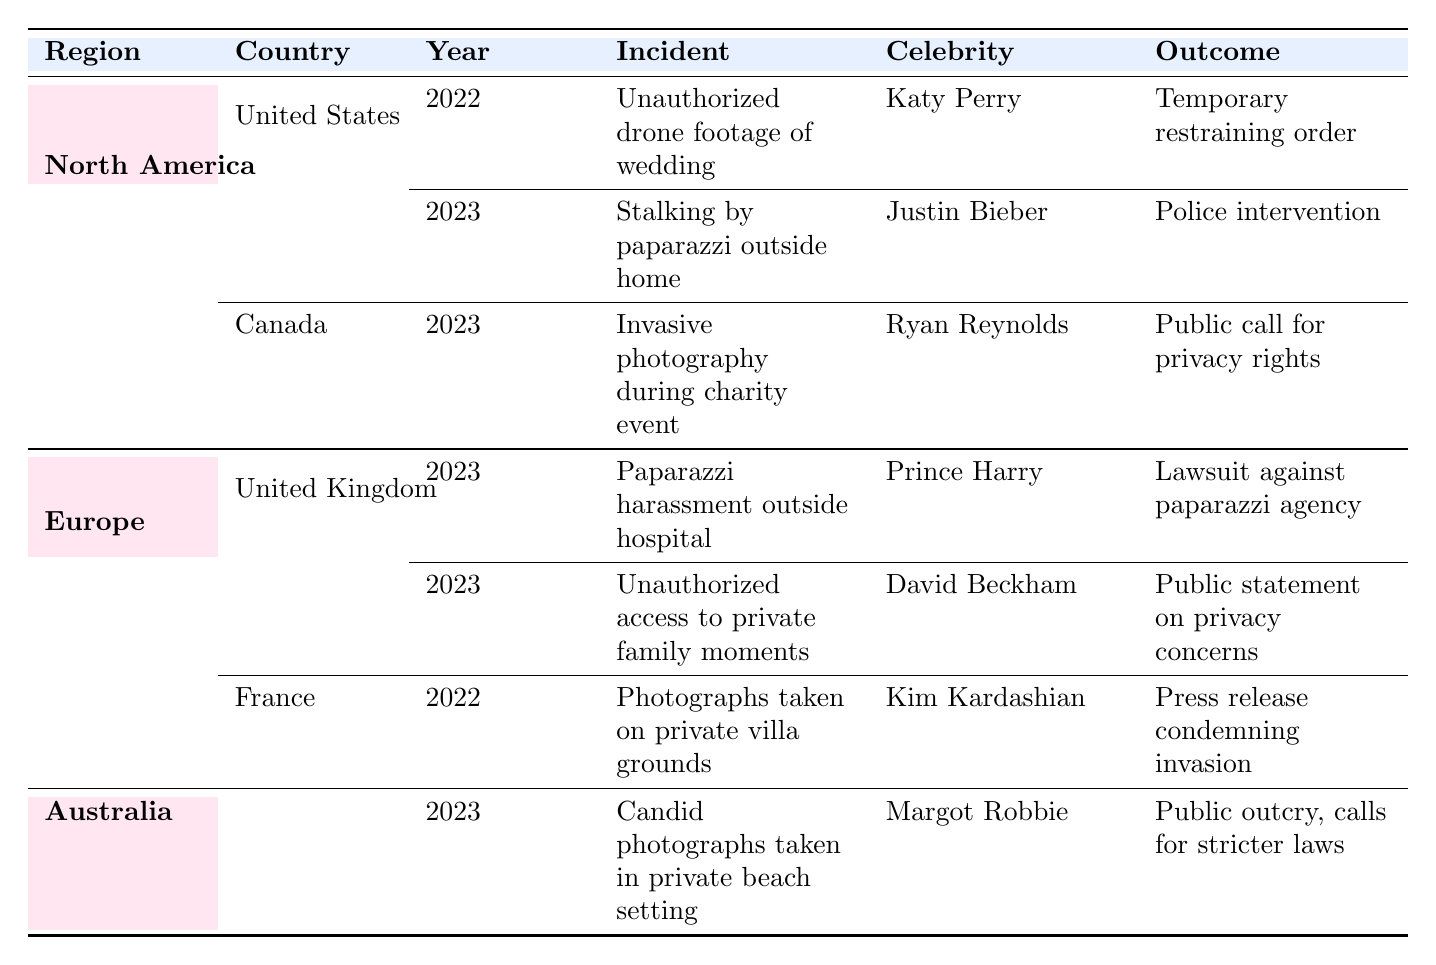What incidents occurred in the United States in 2023? There are two incidents listed for the United States in 2023: one involving "stalking by paparazzi outside a home" related to Justin Bieber, and there is no other incident in that year.
Answer: Stalking by paparazzi outside a home How many privacy invasion incidents were reported in Canada? There is one reported incident in Canada, which involved Ryan Reynolds at a charity event in 2023.
Answer: One incident Which celebrity faced paparazzi harassment outside a hospital in the United Kingdom? The table indicates that Prince Harry was the celebrity who experienced paparazzi harassment outside a hospital in 2023.
Answer: Prince Harry Are there any recorded incidents of privacy invasion in France? Yes, there is one incident recorded in France involving Kim Kardashian, where photographs were taken on private villa grounds in 2022.
Answer: Yes What was the outcome of the incidents in the United States? The outcomes of the incidents were: for Katy Perry, a temporary restraining order against paparazzi was issued; for Justin Bieber, there was police intervention and condemnation of paparazzi practices.
Answer: Temporary restraining order; police intervention What was the location of the incident involving Margot Robbie in Australia, and what was the outcome? The incident involving Margot Robbie occurred at a private beach setting on the Gold Coast, and the outcome was a public outcry with calls for stricter privacy laws.
Answer: Gold Coast; public outcry, calls for stricter laws How many incidents of privacy invasion were reported in Europe? In Europe, there are three incidents listed: two in the United Kingdom and one in France. Adding these gives a total of three incidents.
Answer: Three incidents Which region had the most reported incidents of privacy invasion in celebrity photography? North America had a total of three incidents: two from the United States and one from Canada, which is more than the two incidents from Europe and the one from Australia.
Answer: North America What was the common theme in the outcomes of the incidents involving David Beckham and Kim Kardashian? Both David Beckham and Kim Kardashian addressed the issue of privacy concerns publicly, indicating a pushback against the invasion of privacy in their respective incidents.
Answer: Public statements on privacy concerns 